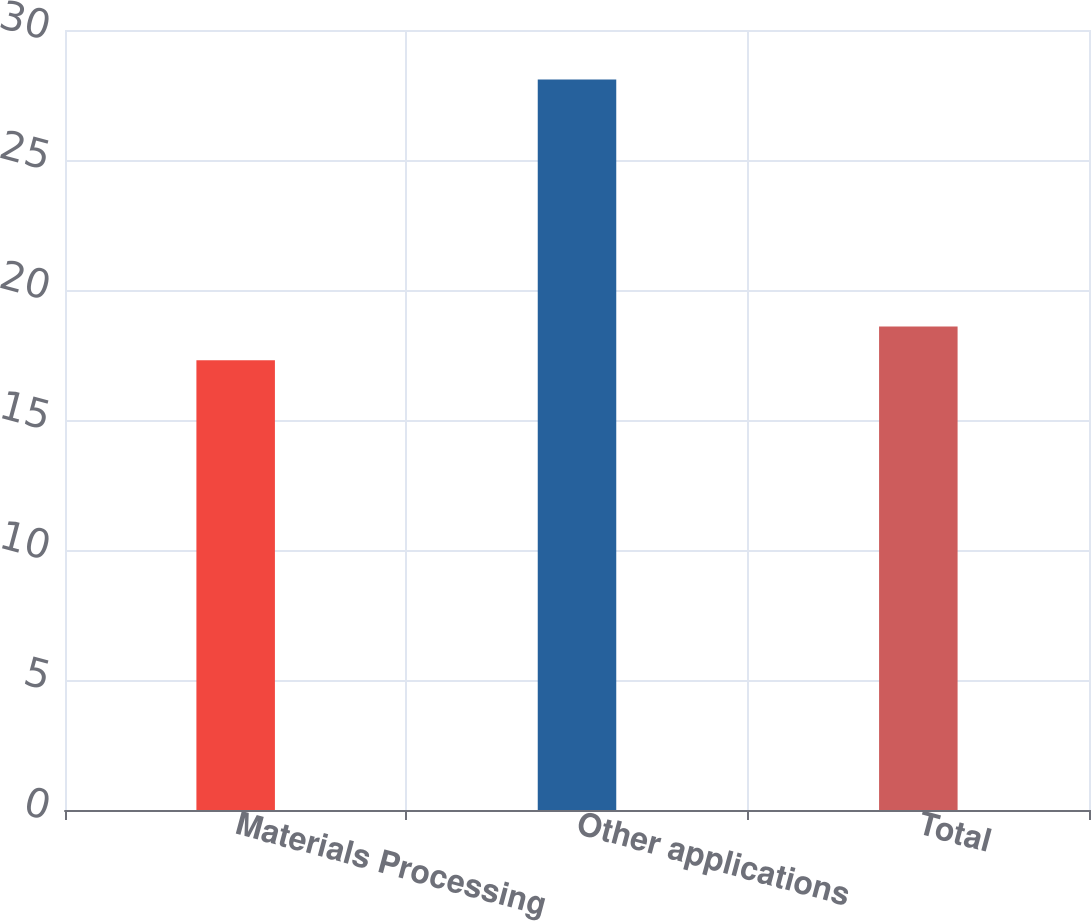Convert chart. <chart><loc_0><loc_0><loc_500><loc_500><bar_chart><fcel>Materials Processing<fcel>Other applications<fcel>Total<nl><fcel>17.3<fcel>28.1<fcel>18.6<nl></chart> 